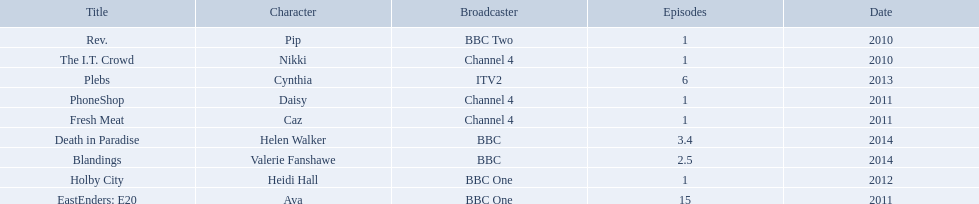Which characters were featured in more then one episode? Ava, Cynthia, Valerie Fanshawe, Helen Walker. Which of these were not in 2014? Ava, Cynthia. Which one of those was not on a bbc broadcaster? Cynthia. 